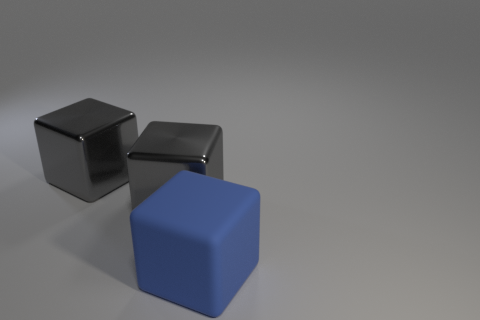What number of blue blocks are behind the blue cube?
Ensure brevity in your answer.  0. How many shiny things are either big gray things or blue blocks?
Make the answer very short. 2. Are there any rubber objects of the same size as the blue matte cube?
Your answer should be compact. No. How many objects are there?
Offer a very short reply. 3. What is the big blue cube made of?
Make the answer very short. Rubber. Are there more gray shiny objects that are behind the blue matte block than big blue matte cubes?
Keep it short and to the point. Yes. What number of other things are there of the same size as the matte object?
Provide a succinct answer. 2. How many small things are either matte cubes or metal cubes?
Keep it short and to the point. 0. What number of objects are either big objects on the left side of the blue block or gray shiny things?
Provide a succinct answer. 2. Are there any gray things that have the same shape as the big blue rubber object?
Offer a terse response. Yes. 